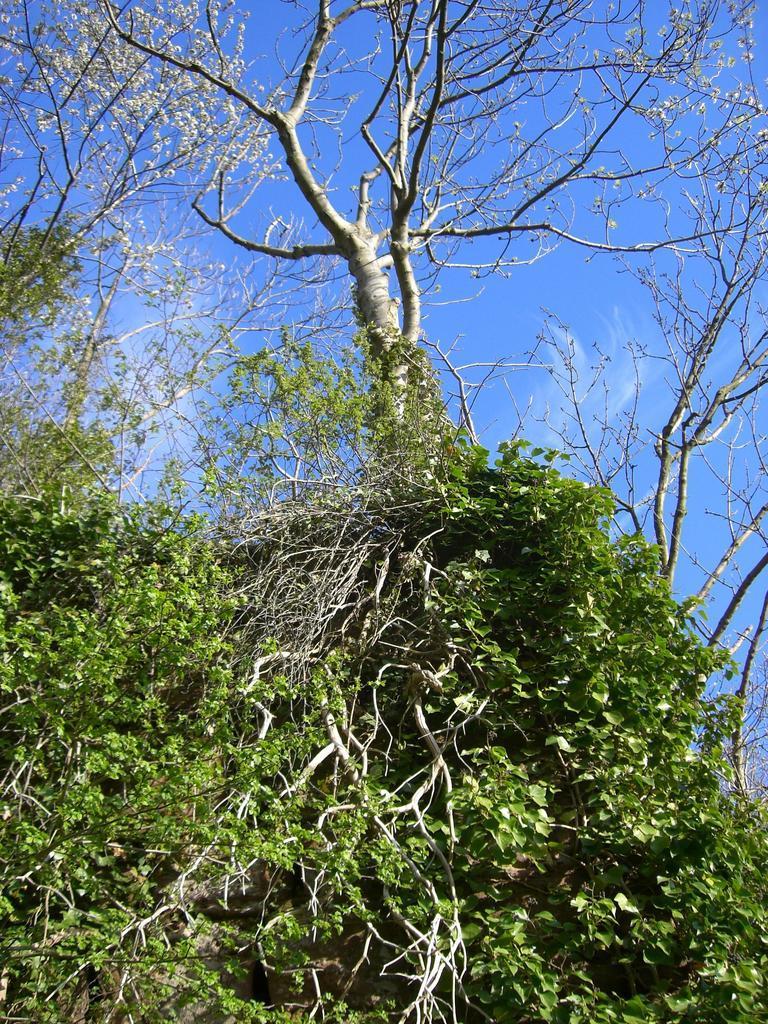How would you summarize this image in a sentence or two? Here we can see trees,green leaves and clouds in the sky. 